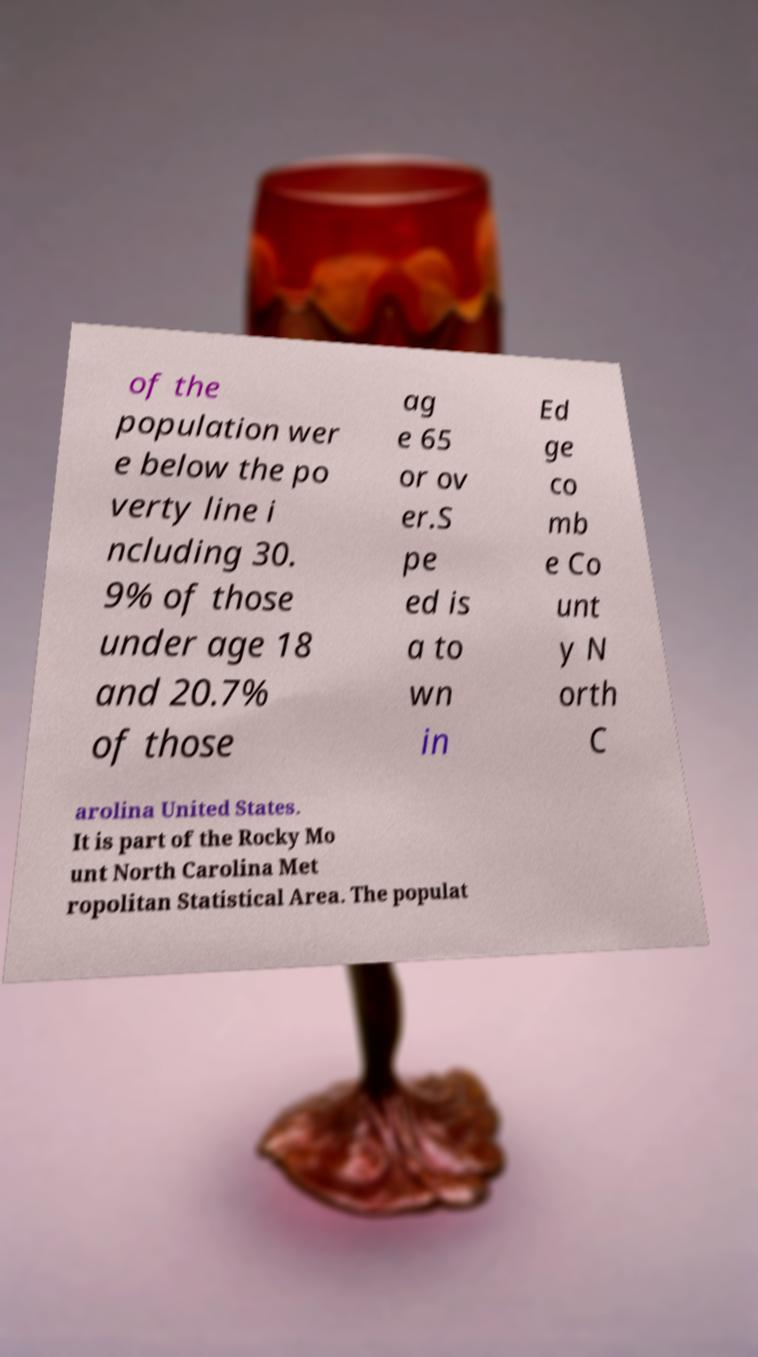I need the written content from this picture converted into text. Can you do that? of the population wer e below the po verty line i ncluding 30. 9% of those under age 18 and 20.7% of those ag e 65 or ov er.S pe ed is a to wn in Ed ge co mb e Co unt y N orth C arolina United States. It is part of the Rocky Mo unt North Carolina Met ropolitan Statistical Area. The populat 